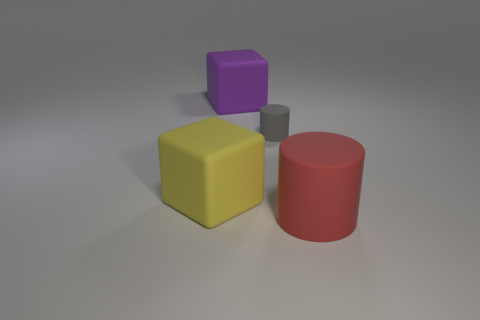Are there any other things that are the same size as the gray thing?
Offer a very short reply. No. There is another large thing that is the same shape as the yellow rubber object; what color is it?
Your answer should be very brief. Purple. Is there any other thing that has the same color as the big rubber cylinder?
Your response must be concise. No. How many rubber things are big cyan blocks or big purple things?
Provide a succinct answer. 1. Is the small thing the same color as the large rubber cylinder?
Provide a short and direct response. No. Are there more yellow cubes that are behind the large purple matte thing than purple things?
Your response must be concise. No. How many other objects are the same material as the large red cylinder?
Give a very brief answer. 3. What number of small objects are either gray cylinders or cylinders?
Your response must be concise. 1. Is the material of the big yellow thing the same as the small gray object?
Your response must be concise. Yes. There is a cylinder that is left of the red object; what number of yellow objects are behind it?
Make the answer very short. 0. 